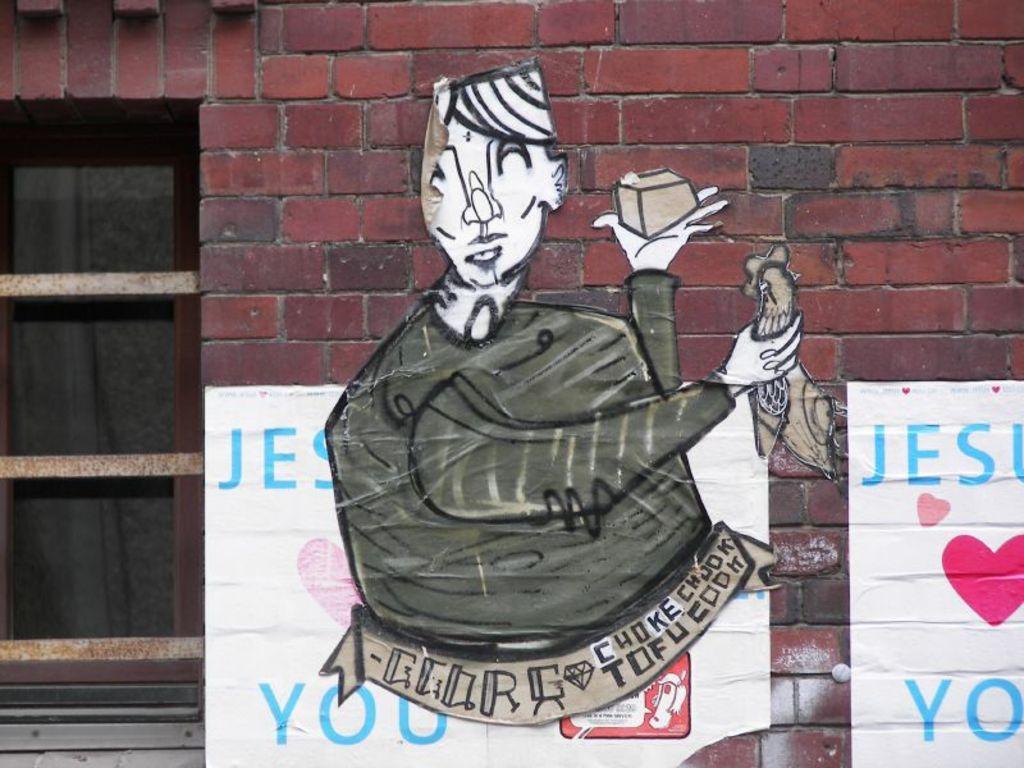Could you give a brief overview of what you see in this image? In this image we can see the brick wall, on the brick wall there are some posters and also we can see a glass window. 